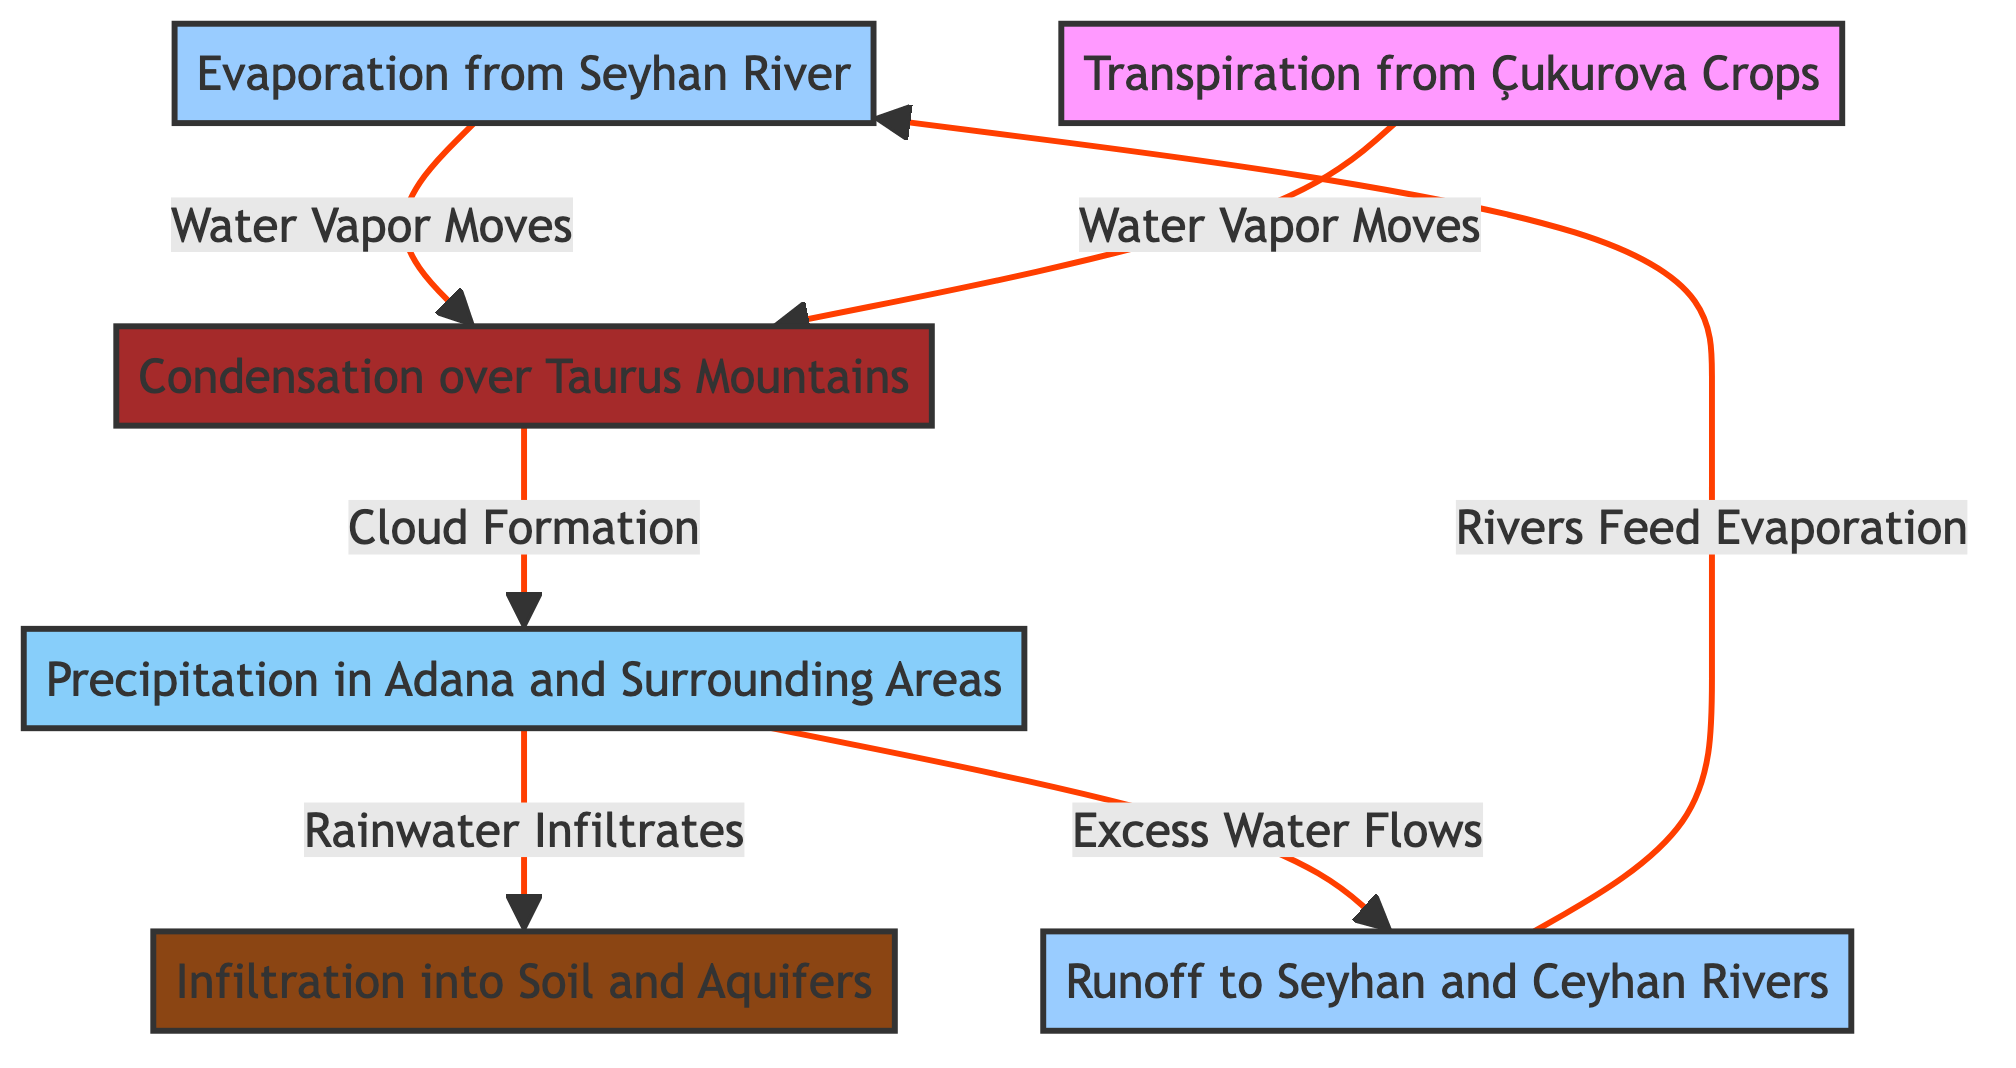What is the first step in the water cycle according to the diagram? The diagram shows the first process is "Evaporation from Seyhan River," which is represented as the starting point in the flowchart.
Answer: Evaporation from Seyhan River How many main processes are depicted in the water cycle? By counting the nodes in the diagram, there are six distinct processes shown, including evaporation, transpiration, condensation, precipitation, infiltration, and runoff.
Answer: 6 What flows directly from "Precipitation in Adana and Surrounding Areas"? The diagram illustrates that "Precipitation in Adana and Surrounding Areas" leads to two outcomes: "Rainwater Infiltrates" into the soil and "Excess Water Flows" into the rivers, indicating that both processes come directly from precipitation.
Answer: Rainwater Infiltrates and Excess Water Flows What is the final process before the cycle repeats? The cycle ends with "Rivers Feed Evaporation," showing that the water flow returns to the starting point, thus completing the cycle.
Answer: Rivers Feed Evaporation What type of relationship exists between "Transpiration from Çukurova Crops" and "Condensation over Taurus Mountains"? The diagram indicates a direct flow labeled "Water Vapor Moves" from "Transpiration from Çukurova Crops" to "Condensation over Taurus Mountains," showing that water vapor generated from crops influences condensation.
Answer: Water Vapor Moves Why does rainfall infiltrate soil and aquifers? The diagram specifies that after precipitation occurs, the water is directed to "Infiltration into Soil and Aquifers," highlighting that rainfall contributes to enriching the soil and replenishing aquifers.
Answer: To enrich soil and replenish aquifers How does runoff relate to the Seyhan and Ceyhan Rivers? The diagram shows that runoff flows into both the "Seyhan and Ceyhan Rivers," indicating that excess water contributes to the water levels in these rivers after precipitation.
Answer: Flows into Seyhan and Ceyhan Rivers Which process takes place at the Taurus Mountains? "Condensation over Taurus Mountains" is the specific process occurring in this location according to the diagram, where water vapor condenses to form clouds.
Answer: Condensation over Taurus Mountains 